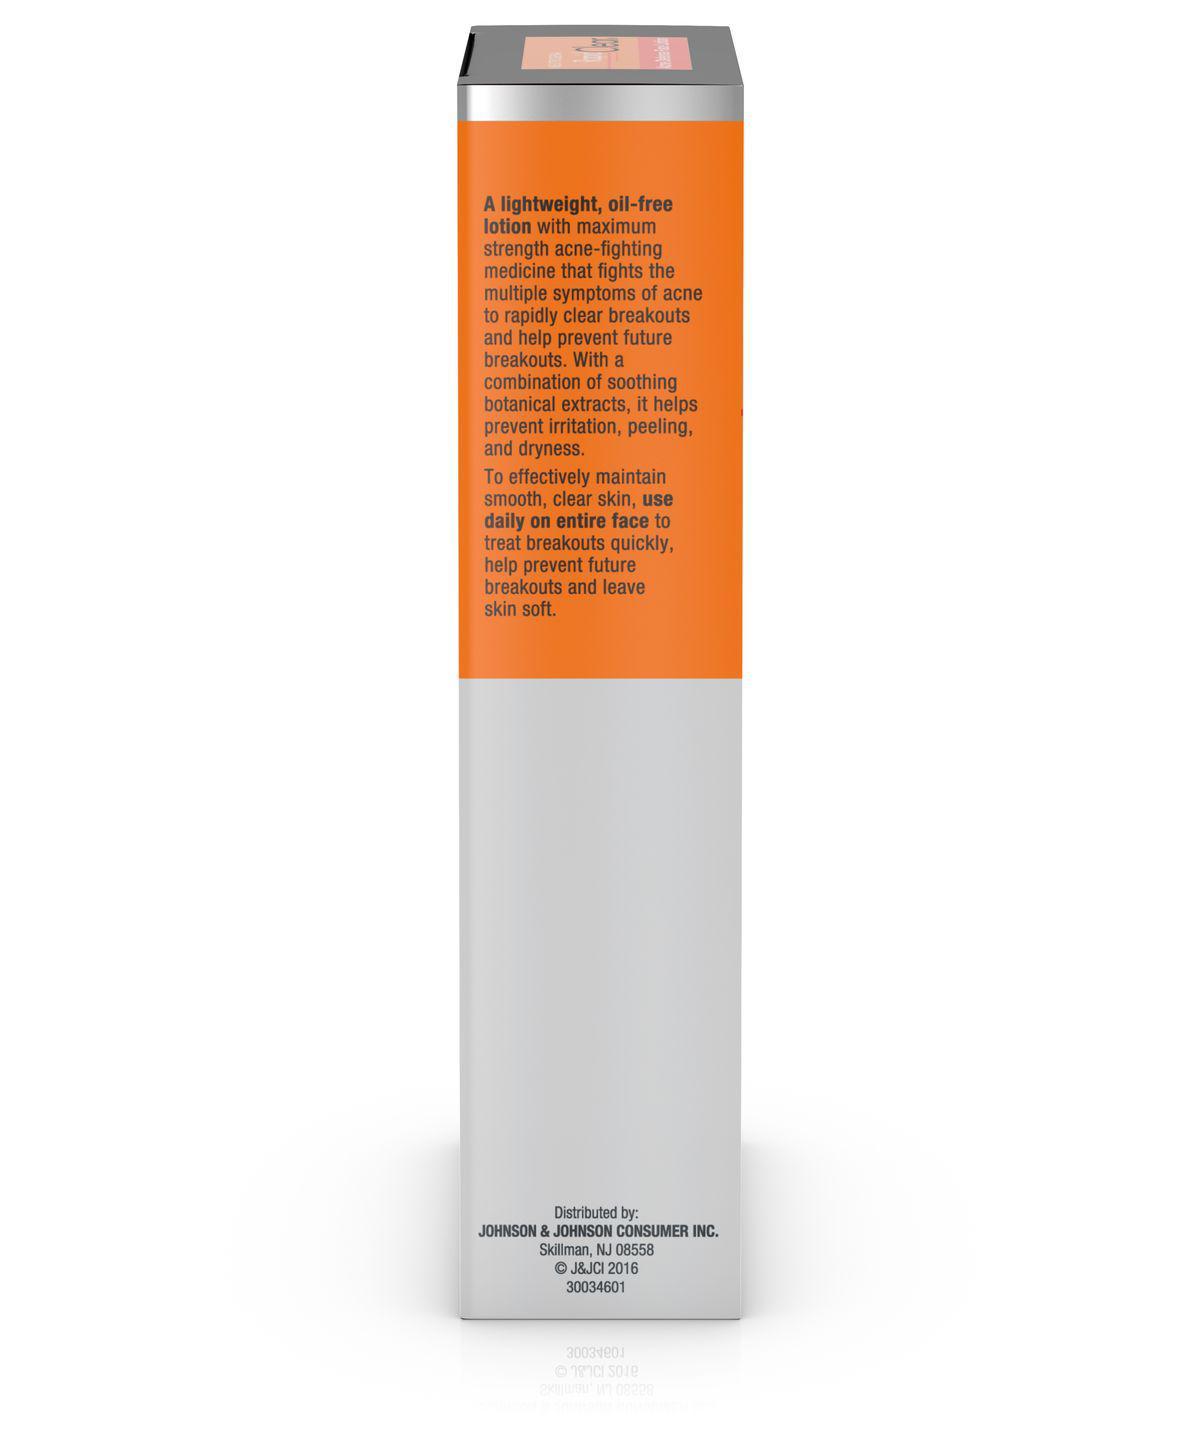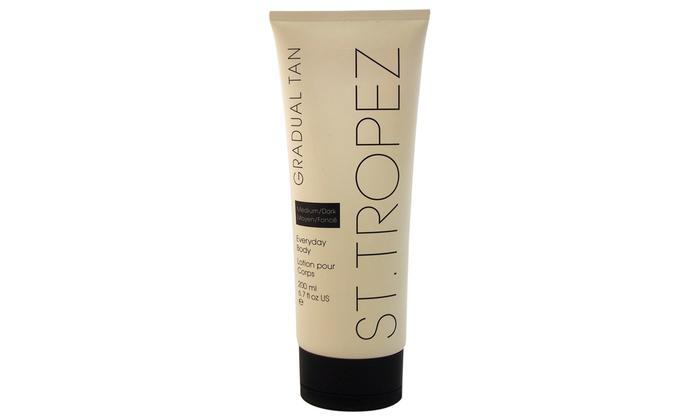The first image is the image on the left, the second image is the image on the right. Considering the images on both sides, is "In one image, a product in a tube stands on end beside the box in which it is packaged to be sold." valid? Answer yes or no. No. The first image is the image on the left, the second image is the image on the right. Analyze the images presented: Is the assertion "Left image shows a product with orange top half and light bottom half." valid? Answer yes or no. Yes. 